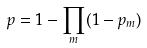<formula> <loc_0><loc_0><loc_500><loc_500>p = 1 - \prod _ { m } ( 1 - p _ { m } )</formula> 